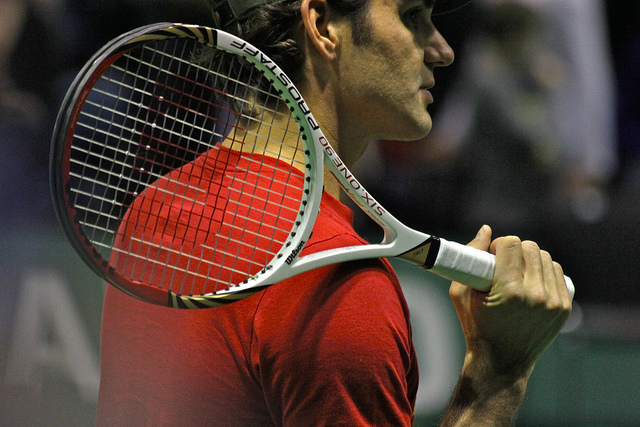Read all the text in this image. 06 ONE SIX 